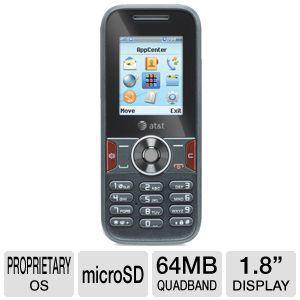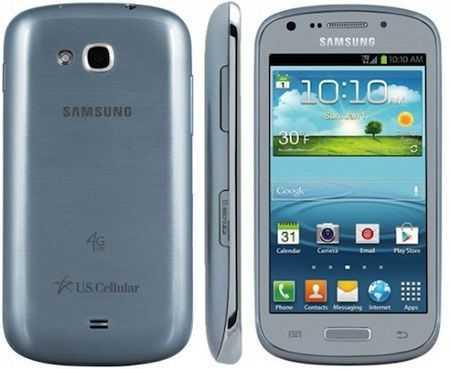The first image is the image on the left, the second image is the image on the right. Analyze the images presented: Is the assertion "A phone's side profile is in the right image." valid? Answer yes or no. Yes. The first image is the image on the left, the second image is the image on the right. Considering the images on both sides, is "There are more phones in the image on the right, and only a single phone in the image on the left." valid? Answer yes or no. Yes. 